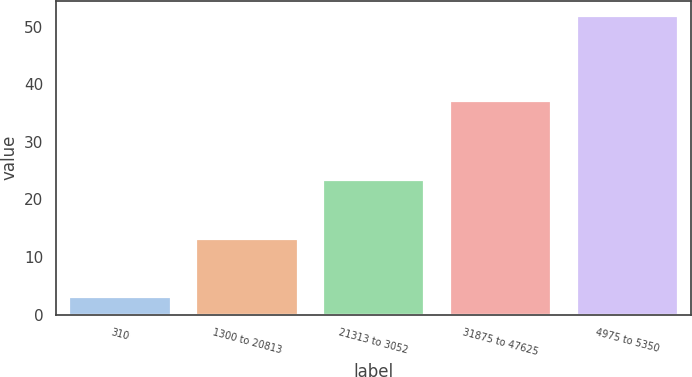Convert chart to OTSL. <chart><loc_0><loc_0><loc_500><loc_500><bar_chart><fcel>310<fcel>1300 to 20813<fcel>21313 to 3052<fcel>31875 to 47625<fcel>4975 to 5350<nl><fcel>3.1<fcel>13.05<fcel>23.39<fcel>37.12<fcel>51.93<nl></chart> 